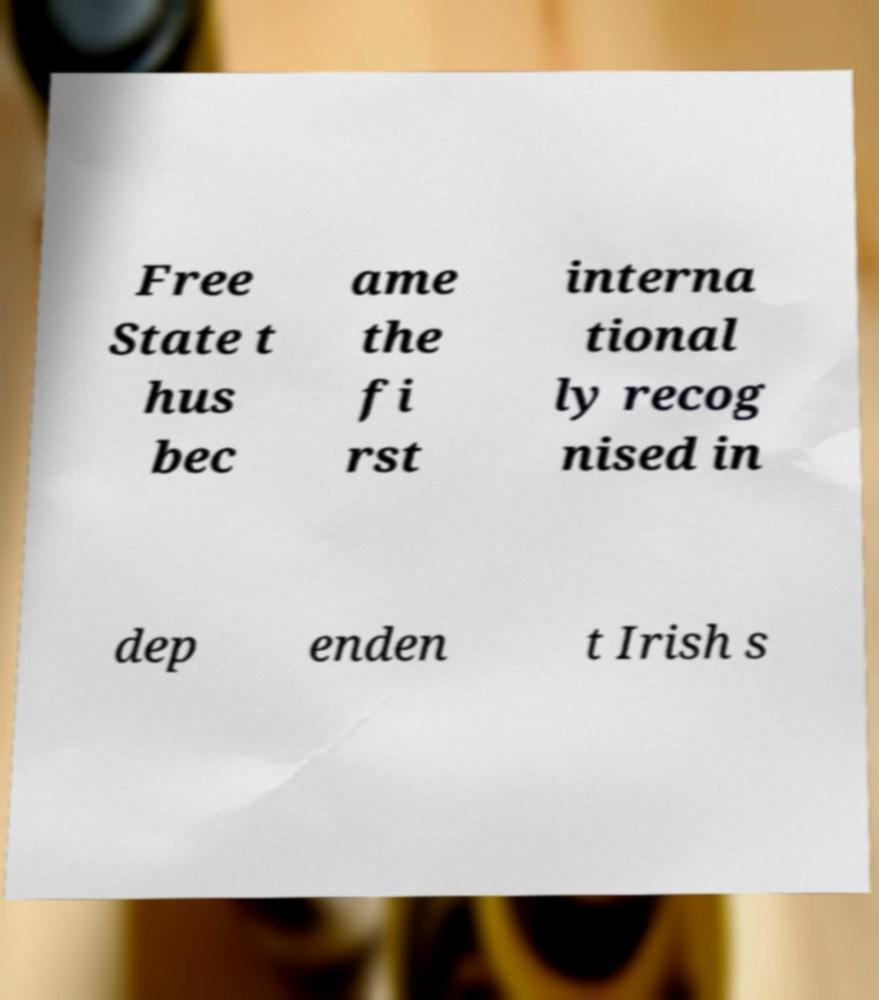Can you accurately transcribe the text from the provided image for me? Free State t hus bec ame the fi rst interna tional ly recog nised in dep enden t Irish s 